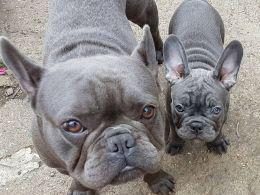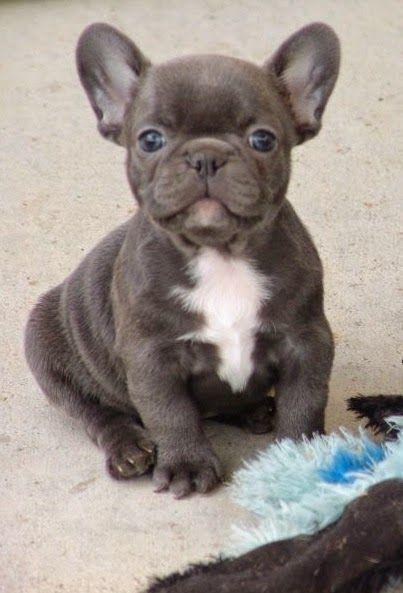The first image is the image on the left, the second image is the image on the right. For the images shown, is this caption "There are two dogs in the left image." true? Answer yes or no. Yes. The first image is the image on the left, the second image is the image on the right. Given the left and right images, does the statement "The left image contains exactly two dogs." hold true? Answer yes or no. Yes. 